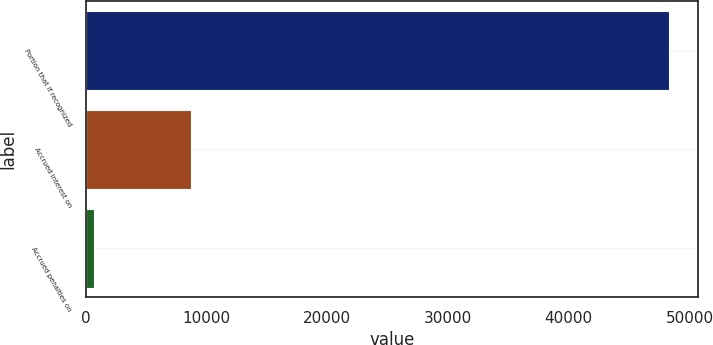<chart> <loc_0><loc_0><loc_500><loc_500><bar_chart><fcel>Portion that if recognized<fcel>Accrued interest on<fcel>Accrued penalties on<nl><fcel>48312<fcel>8750<fcel>673<nl></chart> 